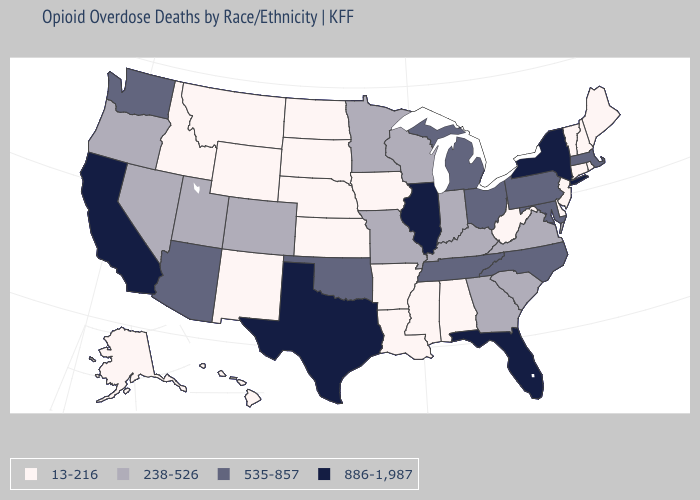Does Missouri have the lowest value in the MidWest?
Concise answer only. No. Name the states that have a value in the range 238-526?
Answer briefly. Colorado, Georgia, Indiana, Kentucky, Minnesota, Missouri, Nevada, Oregon, South Carolina, Utah, Virginia, Wisconsin. How many symbols are there in the legend?
Keep it brief. 4. Name the states that have a value in the range 535-857?
Write a very short answer. Arizona, Maryland, Massachusetts, Michigan, North Carolina, Ohio, Oklahoma, Pennsylvania, Tennessee, Washington. Name the states that have a value in the range 238-526?
Give a very brief answer. Colorado, Georgia, Indiana, Kentucky, Minnesota, Missouri, Nevada, Oregon, South Carolina, Utah, Virginia, Wisconsin. Among the states that border Maryland , does West Virginia have the lowest value?
Quick response, please. Yes. What is the highest value in the USA?
Concise answer only. 886-1,987. How many symbols are there in the legend?
Quick response, please. 4. Which states have the lowest value in the USA?
Keep it brief. Alabama, Alaska, Arkansas, Connecticut, Delaware, Hawaii, Idaho, Iowa, Kansas, Louisiana, Maine, Mississippi, Montana, Nebraska, New Hampshire, New Jersey, New Mexico, North Dakota, Rhode Island, South Dakota, Vermont, West Virginia, Wyoming. Among the states that border Louisiana , which have the lowest value?
Be succinct. Arkansas, Mississippi. Name the states that have a value in the range 886-1,987?
Quick response, please. California, Florida, Illinois, New York, Texas. Does South Dakota have the lowest value in the USA?
Give a very brief answer. Yes. What is the value of Indiana?
Concise answer only. 238-526. Does Vermont have the same value as Oregon?
Keep it brief. No. What is the value of Colorado?
Write a very short answer. 238-526. 